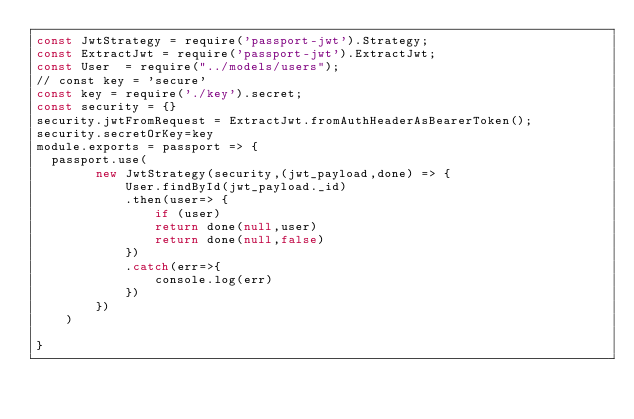Convert code to text. <code><loc_0><loc_0><loc_500><loc_500><_JavaScript_>const JwtStrategy = require('passport-jwt').Strategy;
const ExtractJwt = require('passport-jwt').ExtractJwt;
const User  = require("../models/users");
// const key = 'secure'
const key = require('./key').secret;
const security = {}
security.jwtFromRequest = ExtractJwt.fromAuthHeaderAsBearerToken();
security.secretOrKey=key
module.exports = passport => {
  passport.use(
        new JwtStrategy(security,(jwt_payload,done) => {
            User.findById(jwt_payload._id)
            .then(user=> {
                if (user)
                return done(null,user)
                return done(null,false)
            })
            .catch(err=>{
                console.log(err)
            })
        })
    )
    
} 
</code> 